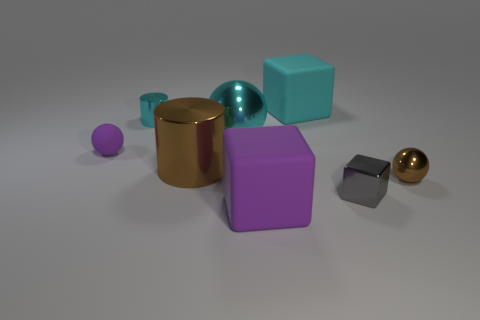What number of other things are there of the same color as the shiny block?
Provide a short and direct response. 0. There is a brown shiny object on the left side of the rubber block behind the brown metal ball; what is its shape?
Your answer should be very brief. Cylinder. There is a gray block; what number of purple rubber things are on the right side of it?
Your answer should be compact. 0. Are there any large things that have the same material as the purple ball?
Your answer should be compact. Yes. What is the material of the purple thing that is the same size as the gray thing?
Offer a terse response. Rubber. There is a rubber object that is both right of the large shiny cylinder and in front of the cyan metal cylinder; what is its size?
Your response must be concise. Large. What color is the matte thing that is both right of the purple rubber ball and behind the tiny metallic block?
Provide a succinct answer. Cyan. Are there fewer large metallic cylinders that are in front of the purple block than cylinders right of the small cyan metal object?
Your answer should be compact. Yes. What number of cyan objects have the same shape as the large brown metallic object?
Provide a short and direct response. 1. What is the size of the cyan thing that is the same material as the cyan sphere?
Your answer should be compact. Small. 